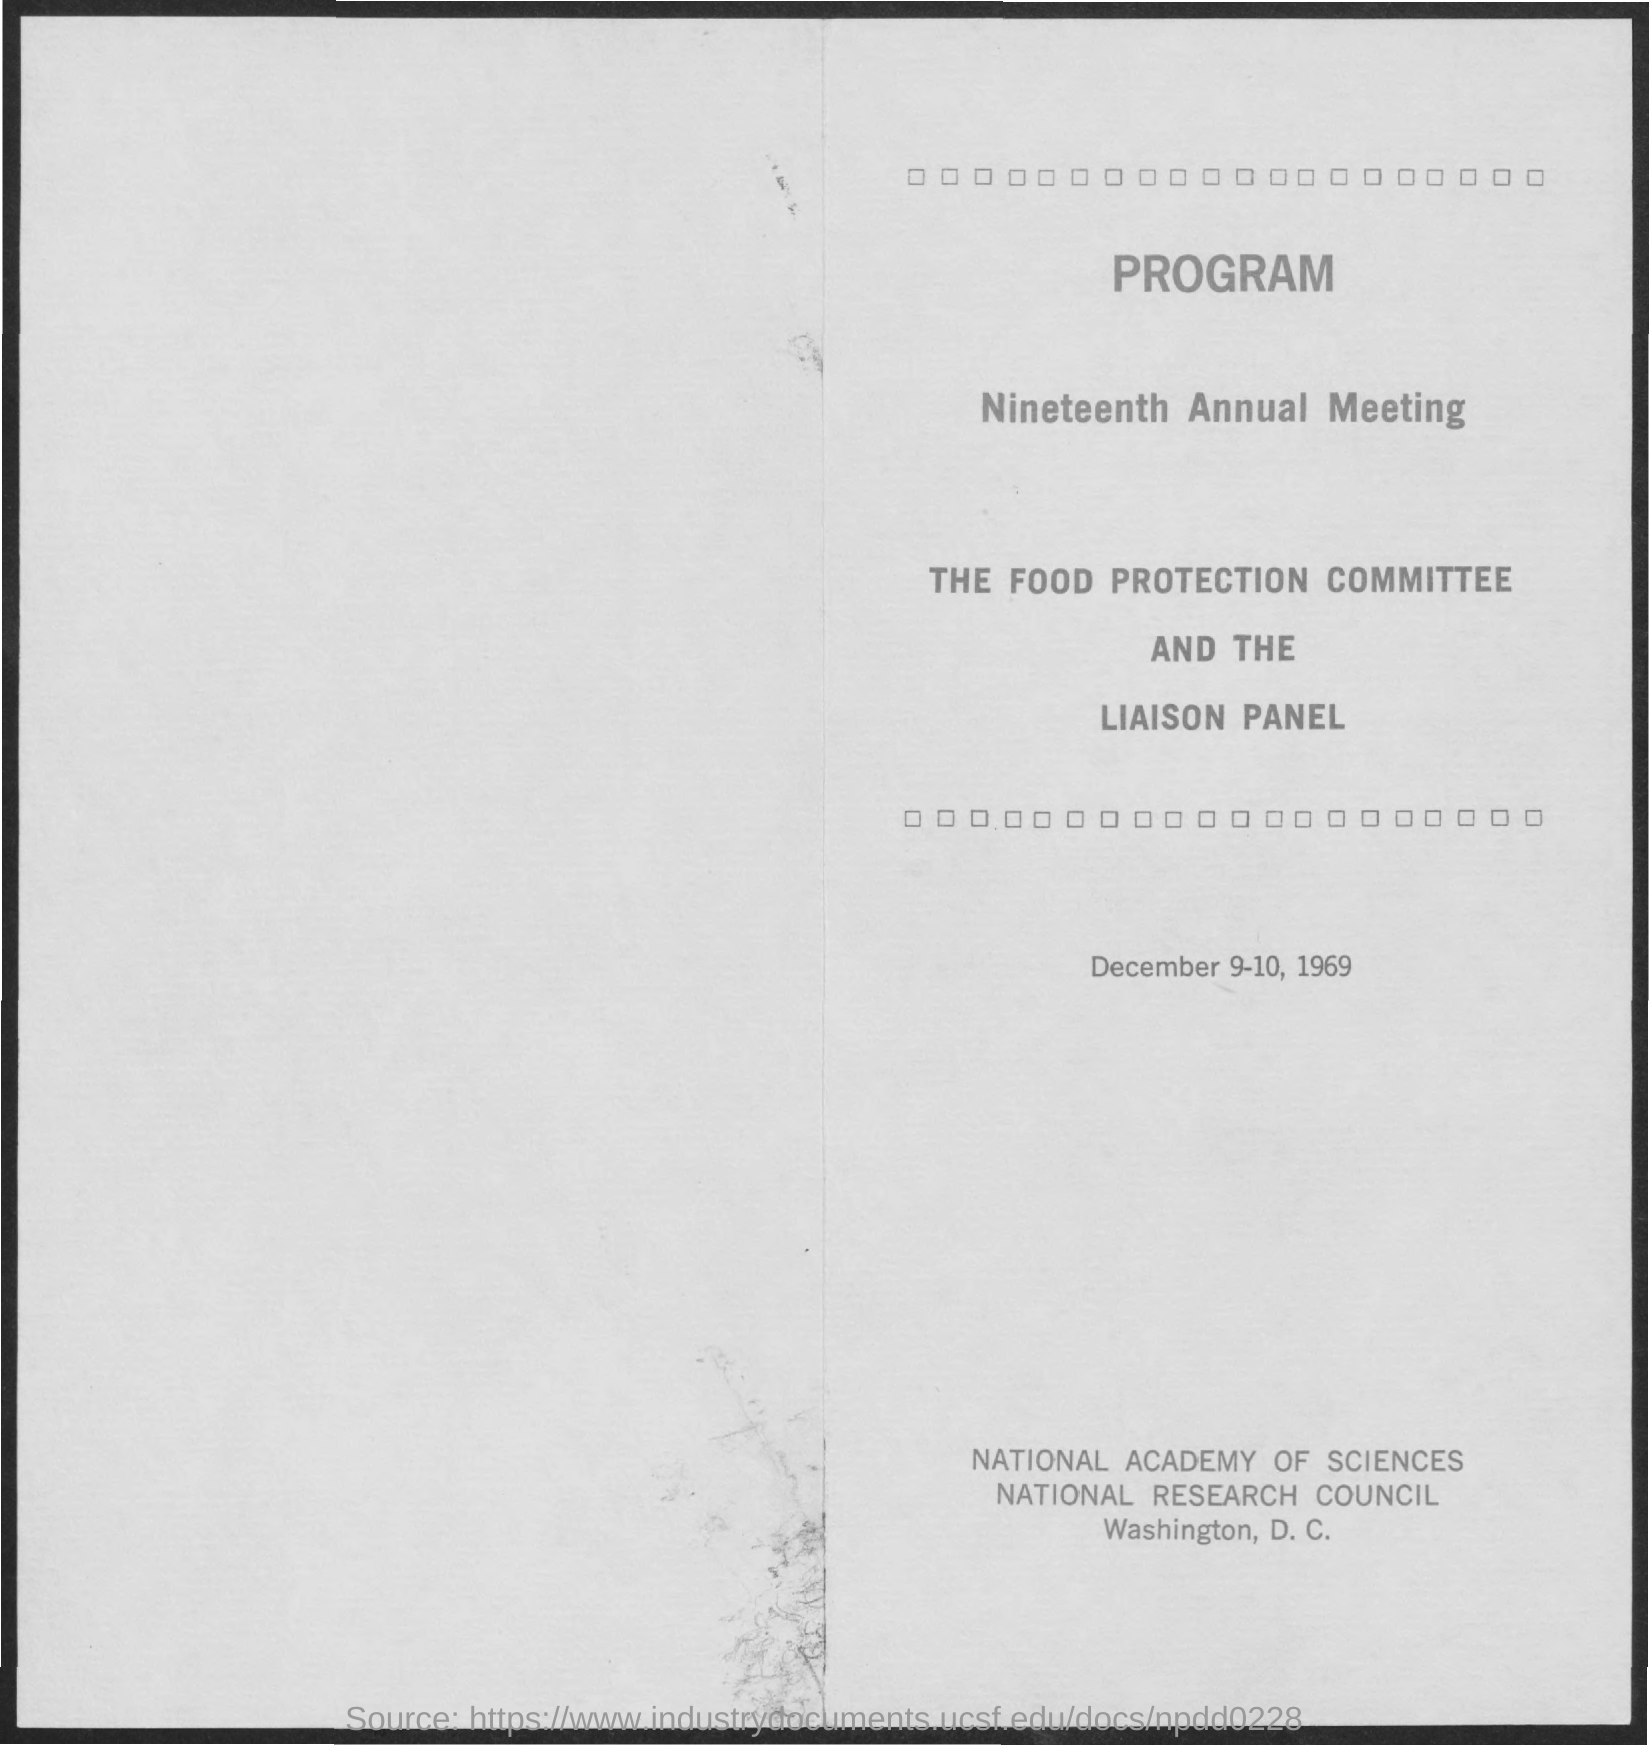Identify some key points in this picture. The second title in the document is 'Nineteenth Annual Meeting...' The document indicates that the date mentioned is December 9-10, 1969. 